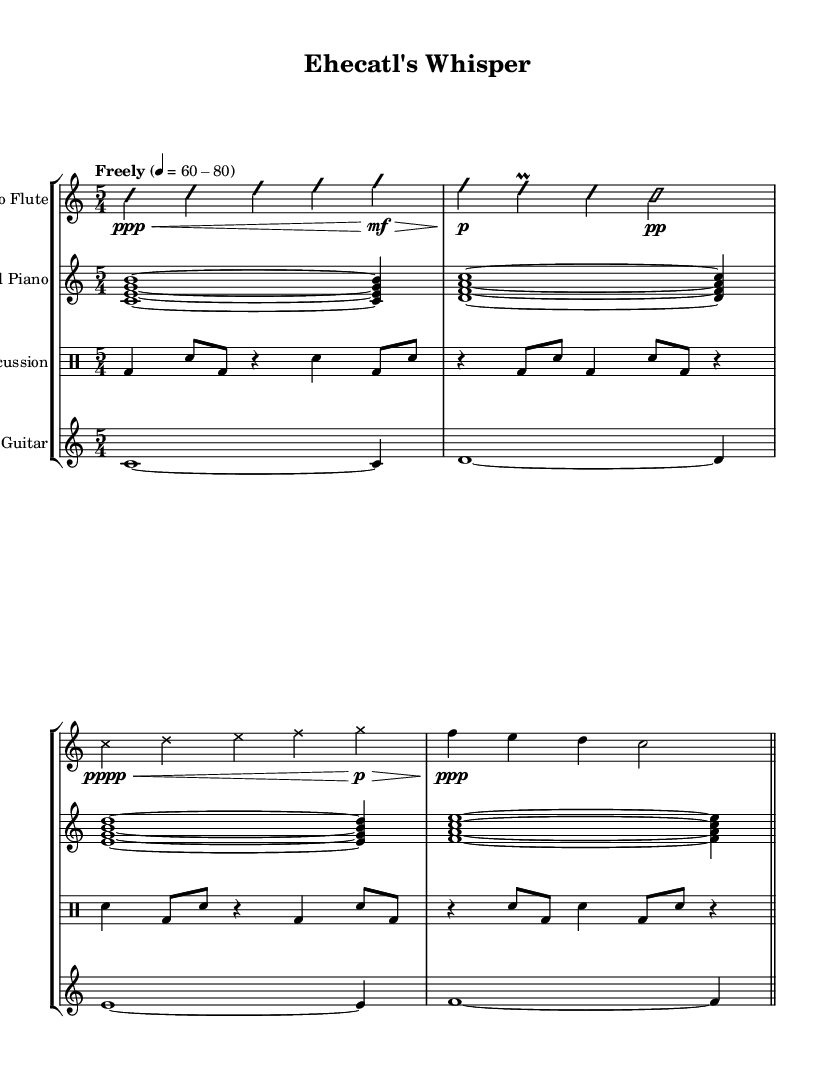What is the time signature of this music? The sheet music indicates a time signature of 5/4, as shown at the beginning of the score.
Answer: 5/4 What is the tempo marking for this piece? The tempo marking is "Freely" with a metronome marking of 60-80 beats per minute, indicated at the start of the score.
Answer: Freely 60-80 Which instruments are included in this composition? The instruments listed in the score are Alto Flute, Prepared Piano, Percussion, and Electric Guitar, as stated in their respective staves.
Answer: Alto Flute, Prepared Piano, Percussion, Electric Guitar How many measures does each part contain? Each part contains 4 measures, as observed by counting the bars in the provided staves for each instrument.
Answer: 4 measures What dynamic marking is indicated for the alto flute at the beginning? The dynamic marking for the alto flute at the beginning is ppp (pianississimo), which is present before the first note in its staff.
Answer: ppp What is the role of the percussion section in this piece? The percussion section performs various rhythmic patterns and accents, contributing to the overall percussive texture, noted in the drum staff.
Answer: Rhythmic patterns What specific technique is used in the prepared piano part? The prepared piano section employs inaudible chords with a specific musical notation, suggesting that it creates a unique sound texture that aligns with the avant-garde style.
Answer: Prepared piano sound texture 